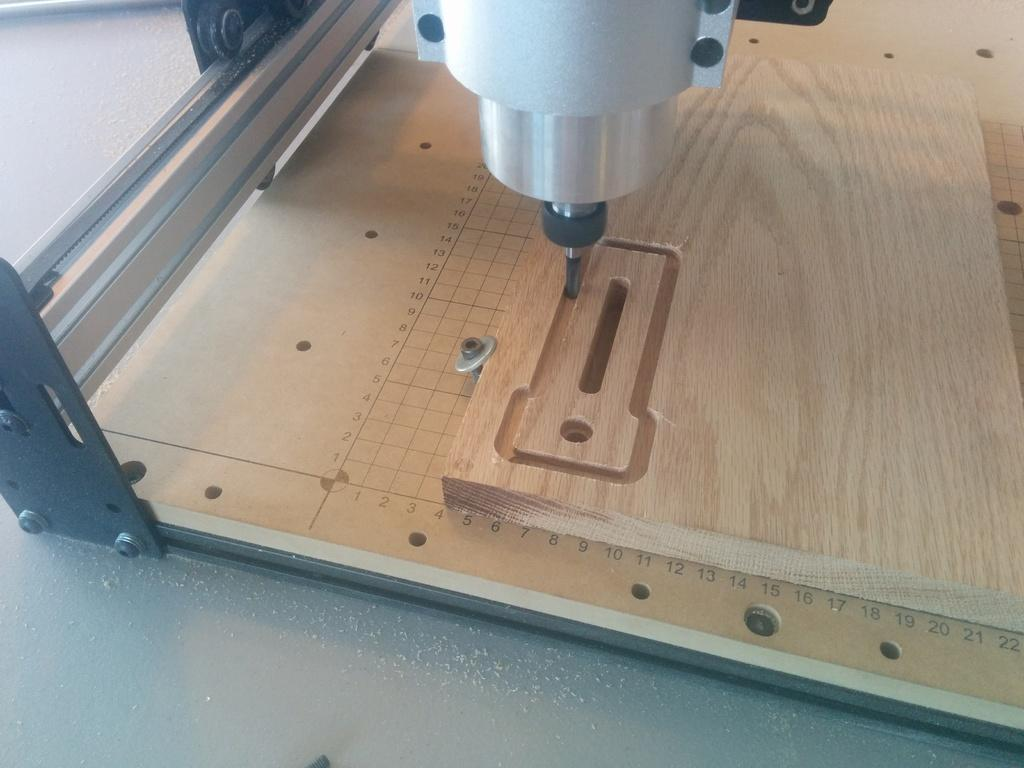What is the main object in the image? There is a piece of plywood in the image. What is positioned above the plywood? There is a drilling machine above the plywood. What can be observed on the plywood? There are holes in the plywood and scale markings on it. What type of brush is being used to create the holes in the plywood? There is no brush present in the image; the holes are being created by a drilling machine. 